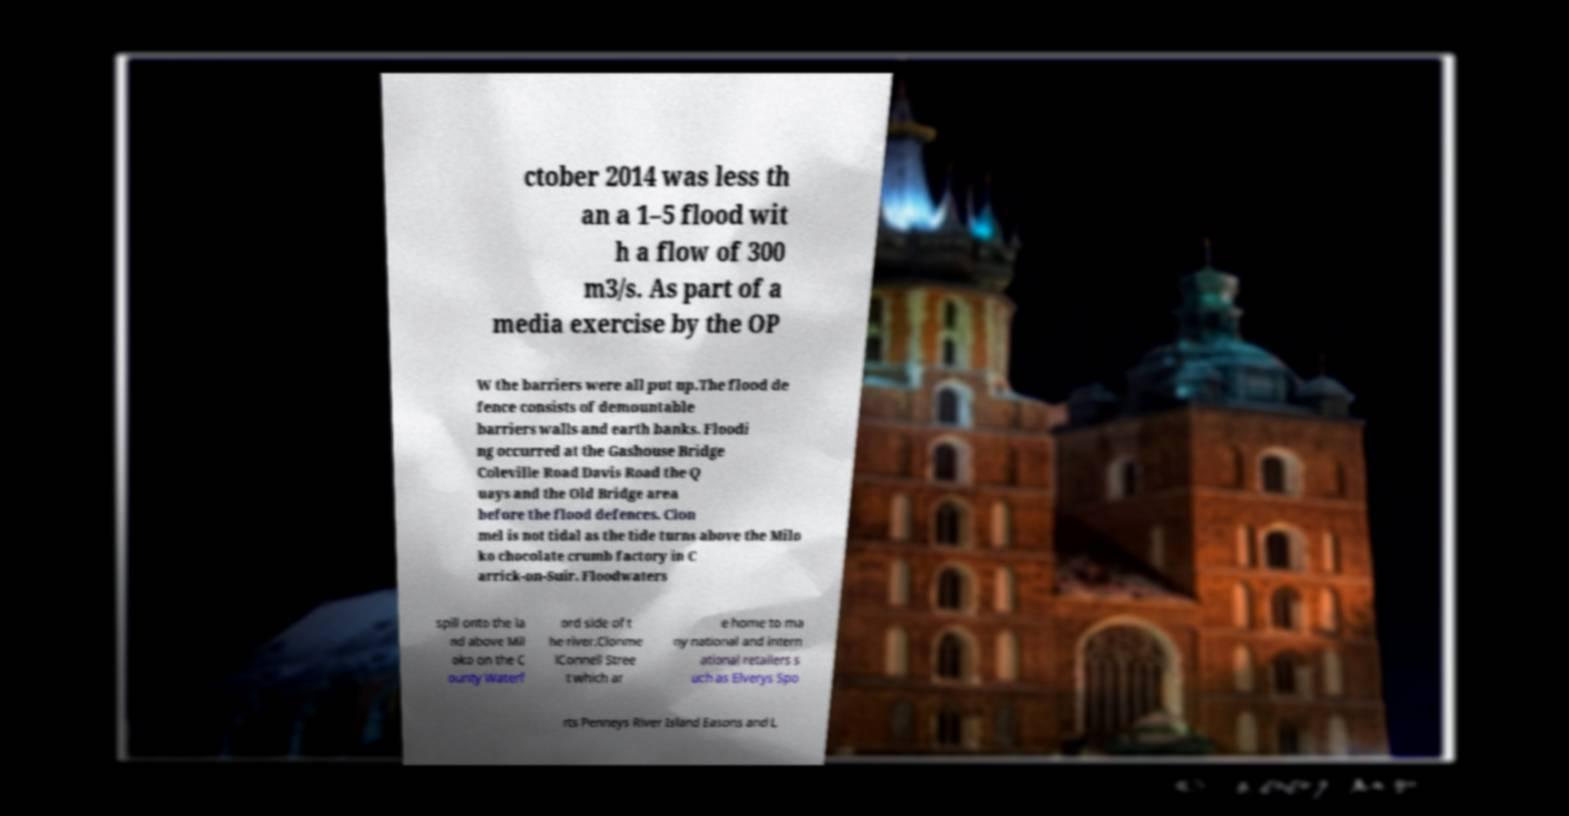There's text embedded in this image that I need extracted. Can you transcribe it verbatim? ctober 2014 was less th an a 1–5 flood wit h a flow of 300 m3/s. As part of a media exercise by the OP W the barriers were all put up.The flood de fence consists of demountable barriers walls and earth banks. Floodi ng occurred at the Gashouse Bridge Coleville Road Davis Road the Q uays and the Old Bridge area before the flood defences. Clon mel is not tidal as the tide turns above the Milo ko chocolate crumb factory in C arrick-on-Suir. Floodwaters spill onto the la nd above Mil oko on the C ounty Waterf ord side of t he river.Clonme lConnell Stree t which ar e home to ma ny national and intern ational retailers s uch as Elverys Spo rts Penneys River Island Easons and L 